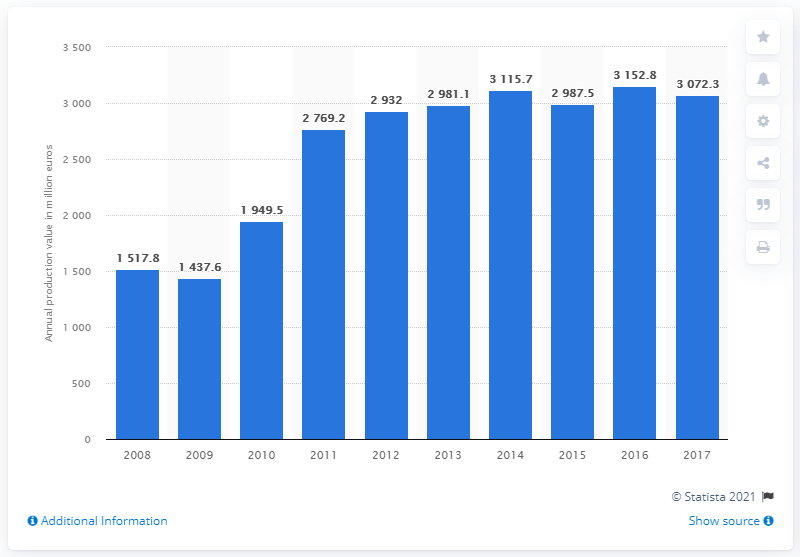Indicate a few pertinent items in this graphic. In 2017, the production value of the Estonian information and communication technology sector was 3,072.3 million euros. 